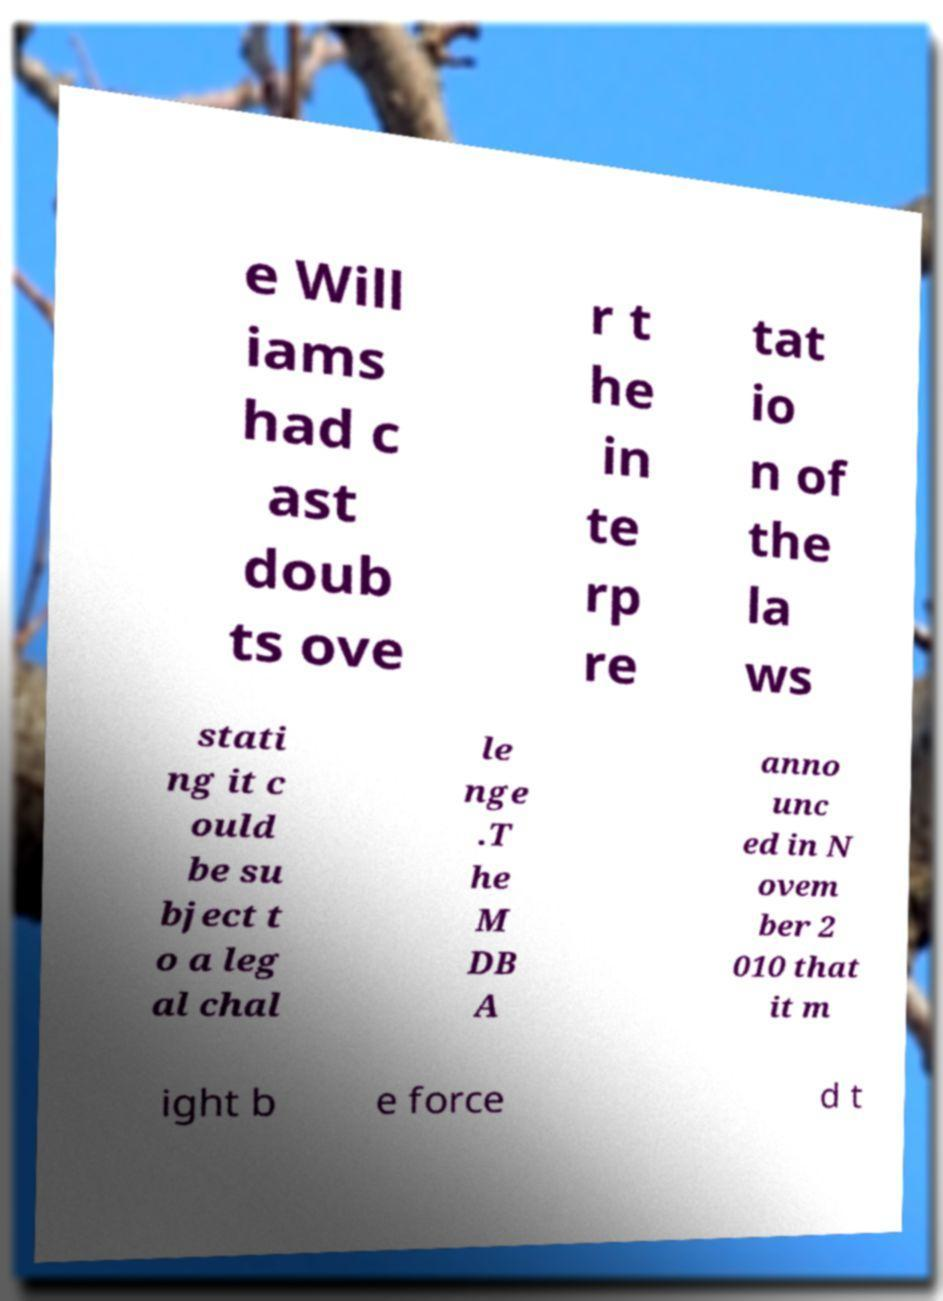I need the written content from this picture converted into text. Can you do that? e Will iams had c ast doub ts ove r t he in te rp re tat io n of the la ws stati ng it c ould be su bject t o a leg al chal le nge .T he M DB A anno unc ed in N ovem ber 2 010 that it m ight b e force d t 